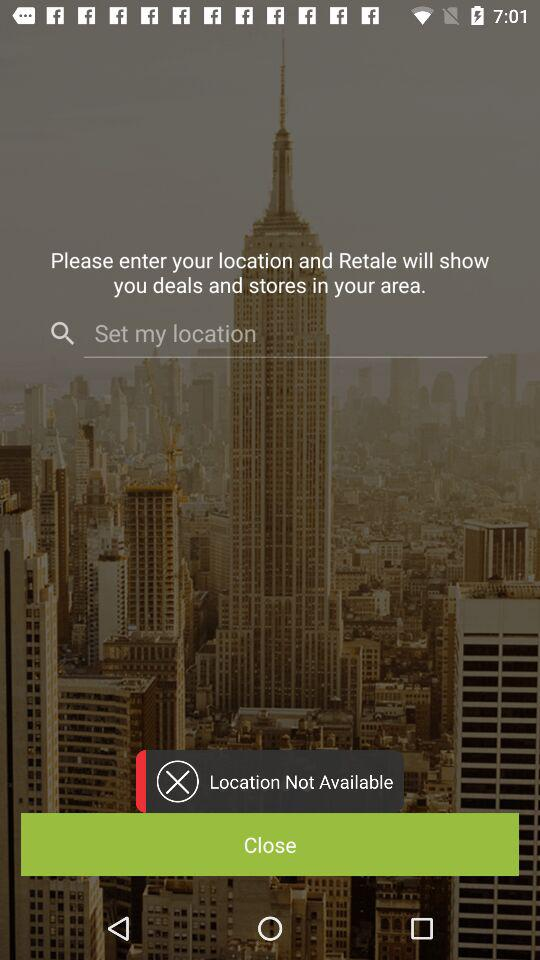How many input fields are on the screen?
Answer the question using a single word or phrase. 1 